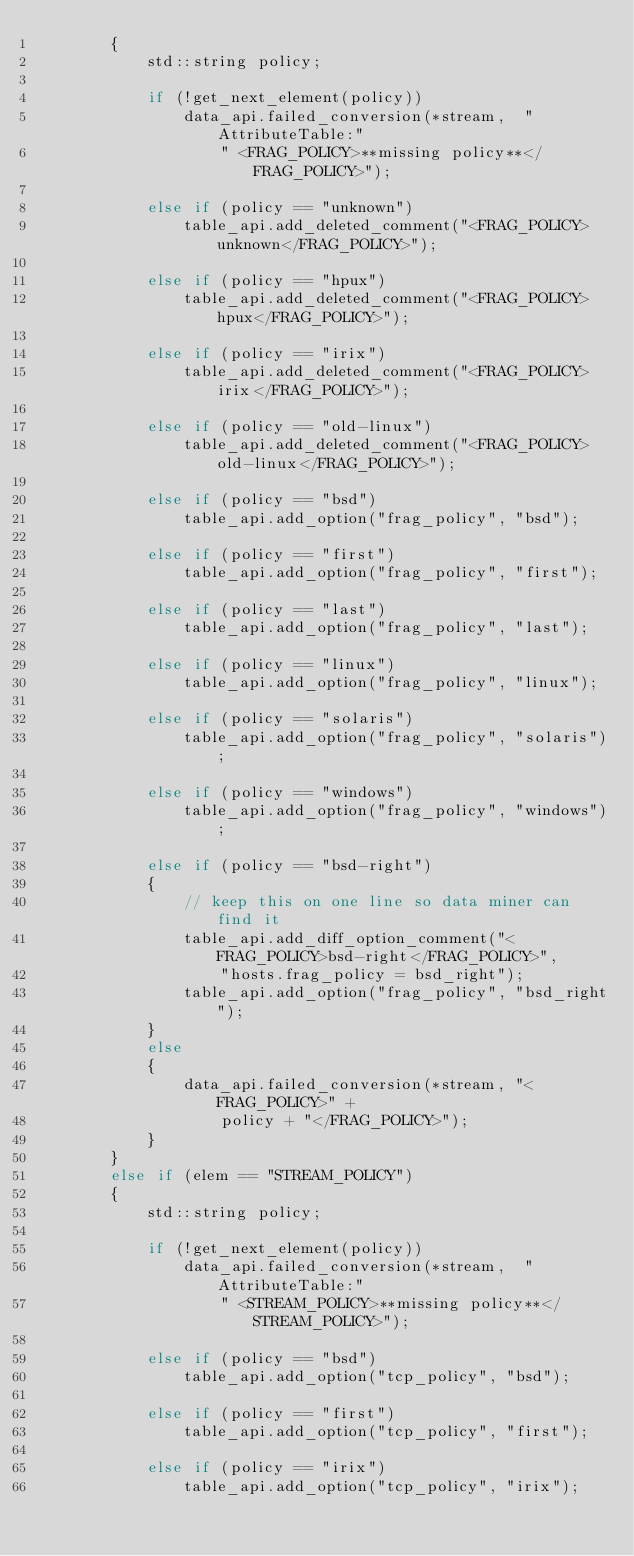Convert code to text. <code><loc_0><loc_0><loc_500><loc_500><_C++_>        {
            std::string policy;

            if (!get_next_element(policy))
                data_api.failed_conversion(*stream,  "AttributeTable:"
                    " <FRAG_POLICY>**missing policy**</FRAG_POLICY>");

            else if (policy == "unknown")
                table_api.add_deleted_comment("<FRAG_POLICY>unknown</FRAG_POLICY>");

            else if (policy == "hpux")
                table_api.add_deleted_comment("<FRAG_POLICY>hpux</FRAG_POLICY>");

            else if (policy == "irix")
                table_api.add_deleted_comment("<FRAG_POLICY>irix</FRAG_POLICY>");

            else if (policy == "old-linux")
                table_api.add_deleted_comment("<FRAG_POLICY>old-linux</FRAG_POLICY>");

            else if (policy == "bsd")
                table_api.add_option("frag_policy", "bsd");

            else if (policy == "first")
                table_api.add_option("frag_policy", "first");

            else if (policy == "last")
                table_api.add_option("frag_policy", "last");

            else if (policy == "linux")
                table_api.add_option("frag_policy", "linux");

            else if (policy == "solaris")
                table_api.add_option("frag_policy", "solaris");

            else if (policy == "windows")
                table_api.add_option("frag_policy", "windows");

            else if (policy == "bsd-right")
            {
                // keep this on one line so data miner can find it
                table_api.add_diff_option_comment("<FRAG_POLICY>bsd-right</FRAG_POLICY>",
                    "hosts.frag_policy = bsd_right");
                table_api.add_option("frag_policy", "bsd_right");
            }
            else
            {
                data_api.failed_conversion(*stream, "<FRAG_POLICY>" +
                    policy + "</FRAG_POLICY>");
            }
        }
        else if (elem == "STREAM_POLICY")
        {
            std::string policy;

            if (!get_next_element(policy))
                data_api.failed_conversion(*stream,  "AttributeTable:"
                    " <STREAM_POLICY>**missing policy**</STREAM_POLICY>");

            else if (policy == "bsd")
                table_api.add_option("tcp_policy", "bsd");

            else if (policy == "first")
                table_api.add_option("tcp_policy", "first");

            else if (policy == "irix")
                table_api.add_option("tcp_policy", "irix");
</code> 